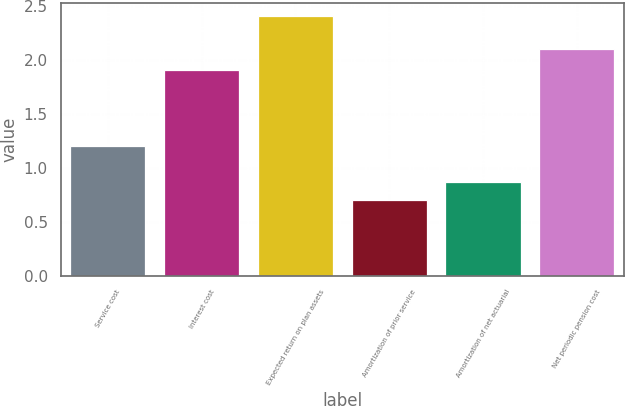Convert chart to OTSL. <chart><loc_0><loc_0><loc_500><loc_500><bar_chart><fcel>Service cost<fcel>Interest cost<fcel>Expected return on plan assets<fcel>Amortization of prior service<fcel>Amortization of net actuarial<fcel>Net periodic pension cost<nl><fcel>1.2<fcel>1.9<fcel>2.4<fcel>0.7<fcel>0.87<fcel>2.1<nl></chart> 